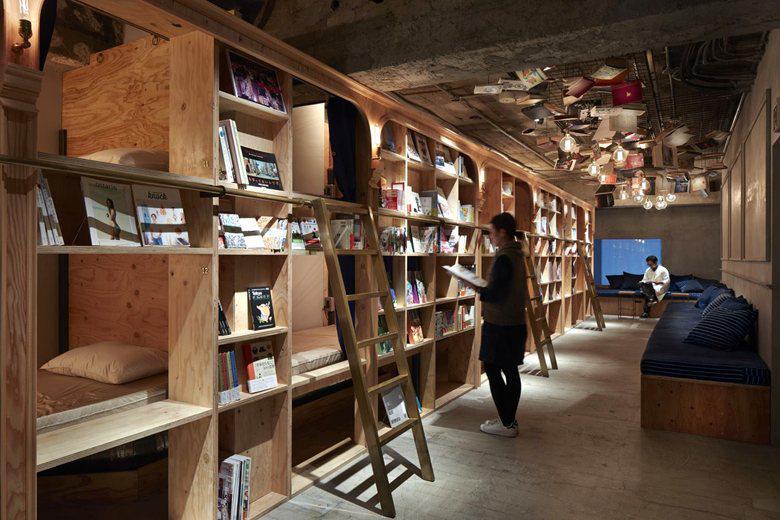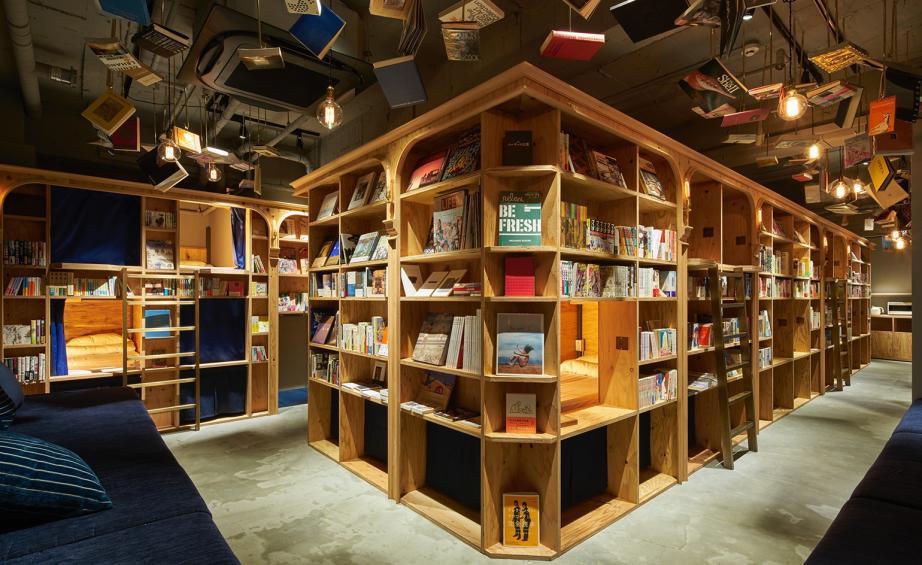The first image is the image on the left, the second image is the image on the right. Given the left and right images, does the statement "A blue seating area sits near the books in the image on the right." hold true? Answer yes or no. Yes. 